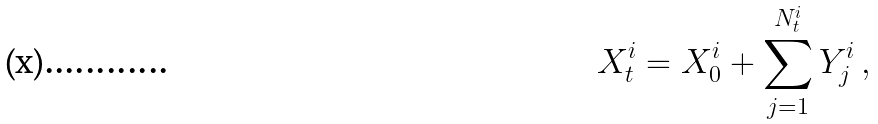Convert formula to latex. <formula><loc_0><loc_0><loc_500><loc_500>X ^ { i } _ { t } = X ^ { i } _ { 0 } + \sum _ { j = 1 } ^ { N ^ { i } _ { t } } Y ^ { i } _ { j } \, ,</formula> 